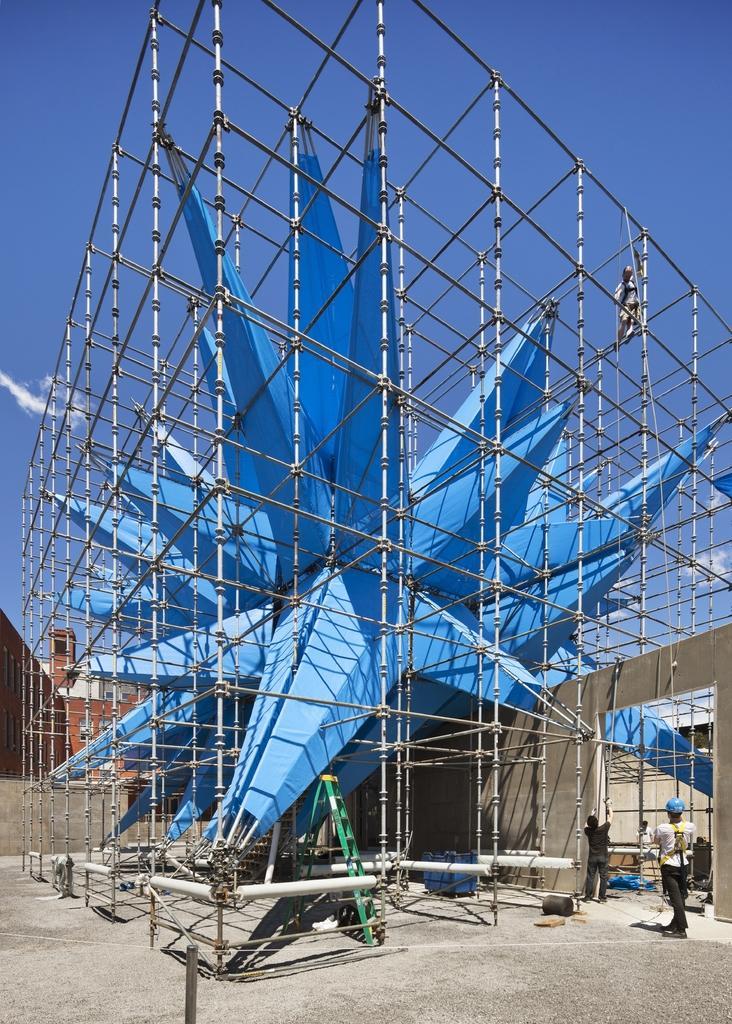Can you describe this image briefly? In the middle of this image there is a blue color structure. Around this there are many poles. It seems to be under construction. At the bottom, I can see the ground. On the right side there are two persons standing facing towards the back side. In the background there are few buildings. At the top of the image I can see the sky. 